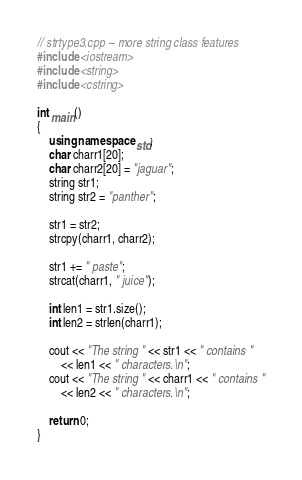Convert code to text. <code><loc_0><loc_0><loc_500><loc_500><_C++_>// strtype3.cpp -- more string class features
#include <iostream>
#include <string>
#include <cstring>

int main()
{
	using namespace std;
	char charr1[20];
	char charr2[20] = "jaguar";
	string str1;
	string str2 = "panther";

	str1 = str2;
	strcpy(charr1, charr2);

	str1 += " paste";
	strcat(charr1, " juice");

	int len1 = str1.size();
	int len2 = strlen(charr1);

	cout << "The string " << str1 << " contains "
		<< len1 << " characters.\n";
	cout << "The string " << charr1 << " contains "
		<< len2 << " characters.\n";

	return 0;
}
</code> 